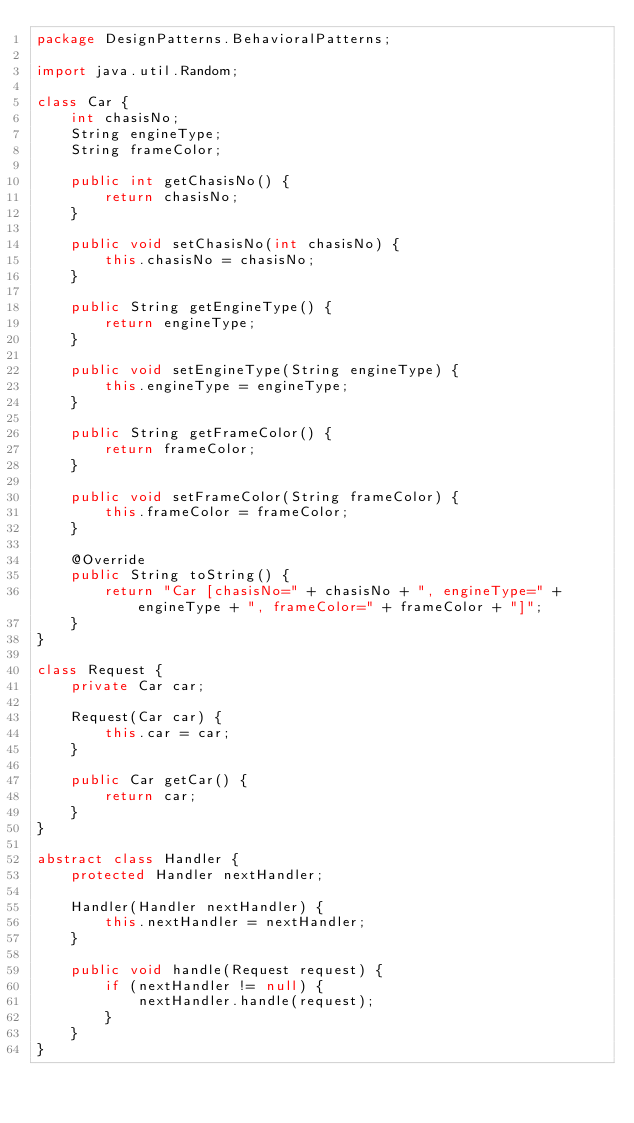<code> <loc_0><loc_0><loc_500><loc_500><_Java_>package DesignPatterns.BehavioralPatterns;

import java.util.Random;

class Car {
    int chasisNo;
    String engineType;
    String frameColor;

    public int getChasisNo() {
        return chasisNo;
    }

    public void setChasisNo(int chasisNo) {
        this.chasisNo = chasisNo;
    }

    public String getEngineType() {
        return engineType;
    }

    public void setEngineType(String engineType) {
        this.engineType = engineType;
    }

    public String getFrameColor() {
        return frameColor;
    }

    public void setFrameColor(String frameColor) {
        this.frameColor = frameColor;
    }

    @Override
    public String toString() {
        return "Car [chasisNo=" + chasisNo + ", engineType=" + engineType + ", frameColor=" + frameColor + "]";
    }
}

class Request {
    private Car car;

    Request(Car car) {
        this.car = car;
    }

    public Car getCar() {
        return car;
    }
}

abstract class Handler {
    protected Handler nextHandler;

    Handler(Handler nextHandler) {
        this.nextHandler = nextHandler;
    }

    public void handle(Request request) {
        if (nextHandler != null) {
            nextHandler.handle(request);
        }
    }
}
</code> 